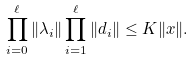<formula> <loc_0><loc_0><loc_500><loc_500>\prod _ { i = 0 } ^ { \ell } \| \lambda _ { i } \| \prod _ { i = 1 } ^ { \ell } \| d _ { i } \| \leq K \| x \| .</formula> 